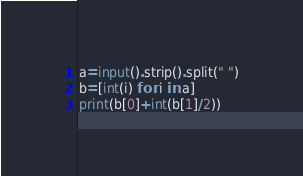<code> <loc_0><loc_0><loc_500><loc_500><_Python_>a=input().strip().split(" ")
b=[int(i) for i in a]
print(b[0]+int(b[1]/2))
</code> 